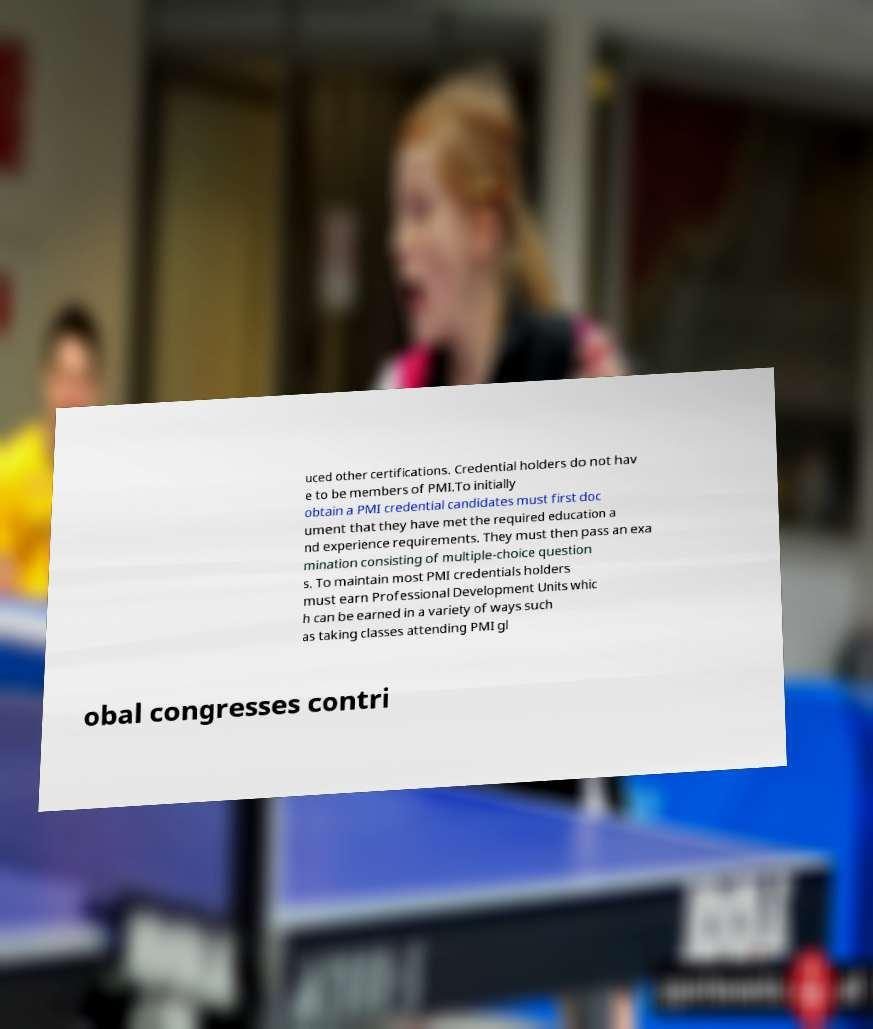Could you assist in decoding the text presented in this image and type it out clearly? uced other certifications. Credential holders do not hav e to be members of PMI.To initially obtain a PMI credential candidates must first doc ument that they have met the required education a nd experience requirements. They must then pass an exa mination consisting of multiple-choice question s. To maintain most PMI credentials holders must earn Professional Development Units whic h can be earned in a variety of ways such as taking classes attending PMI gl obal congresses contri 